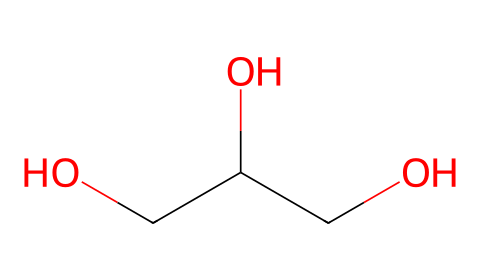What is the molecular formula of glycerol? The SMILES representation indicates three carbon atoms (C), eight hydrogen atoms (H), and three oxygen atoms (O), leading to the molecular formula C3H8O3.
Answer: C3H8O3 How many hydroxyl (–OH) groups are present in glycerol? By examining the structure, we can see there are three –OH groups attached to the carbon skeleton, indicating that glycerol has three hydroxyl groups.
Answer: three What type of chemical is glycerol classified as? Glycerol is categorized as a polyol because it contains multiple hydroxyl groups, which is characteristic of polyols, also known as sugar alcohols.
Answer: polyol How many carbon atoms are in the structure of glycerol? In the SMILES representation, we identify three carbon atoms, which can be counted directly from the structure.
Answer: three Is glycerol soluble in water? Glycerol is hydrophilic due to its multiple hydroxyl groups, making it soluble in water.
Answer: yes Which property of glycerol makes it an effective solvent in e-cigarette liquids? The presence of multiple hydroxyl groups provides good solubility for other components, allowing glycerol to effectively dissolve flavors and nicotine in e-cigarette liquids.
Answer: solubility What functional groups are present in glycerol? The main functional group in glycerol is the hydroxyl group (-OH), and there are three such groups found in its structure.
Answer: hydroxyl groups 